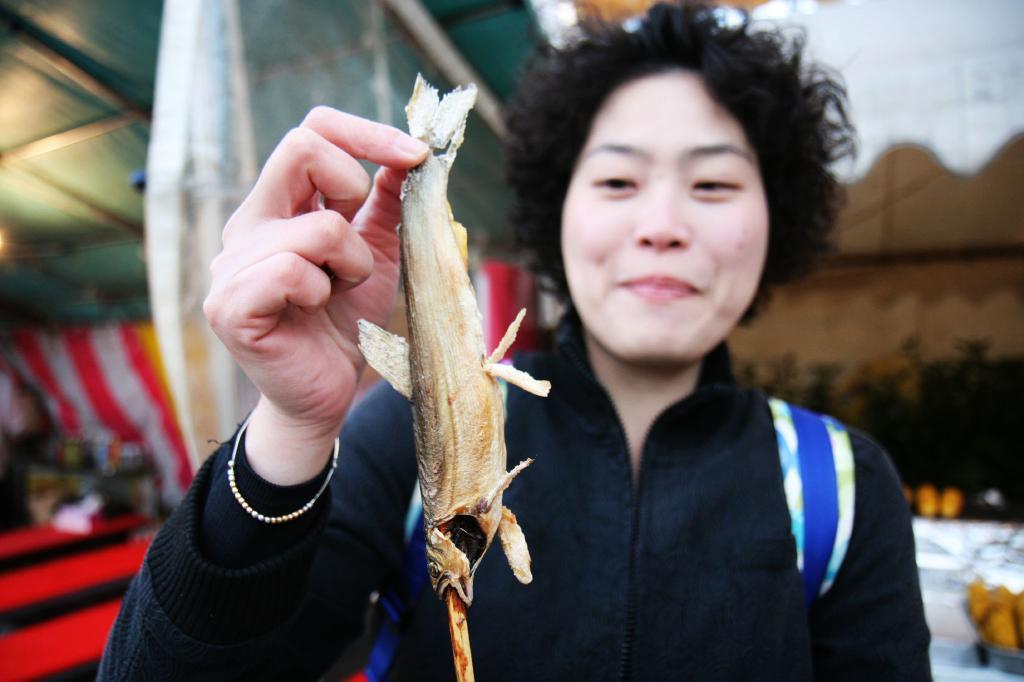Could you give a brief overview of what you see in this image? A person is holding the fish, this person wore black color coat and also smiling. 